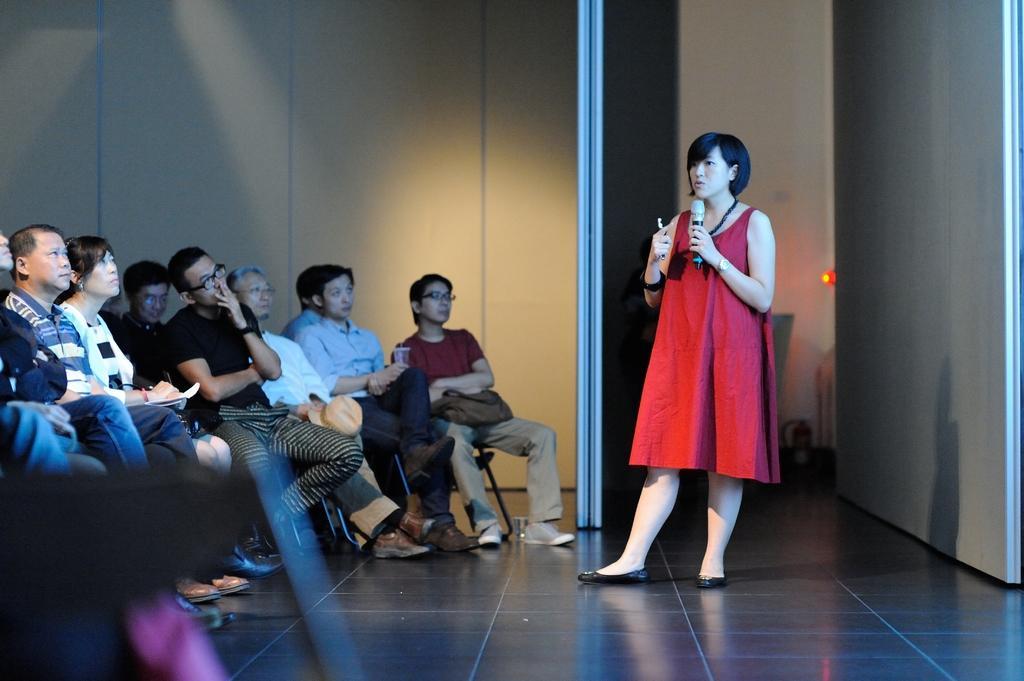How would you summarize this image in a sentence or two? This image consists of many people. To the right, there is a woman wearing red dress is talking in a mic. To the left, there are many people sitting in the chairs. At the bottom, there is a floor. In the background, there is a wall. 